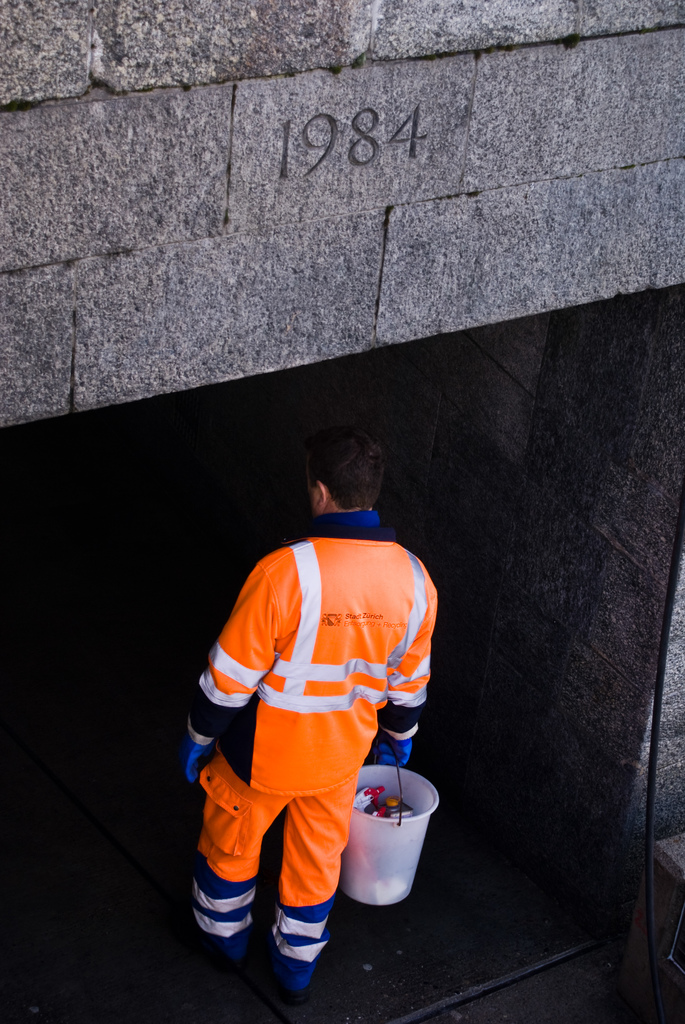How does the uniform he's wearing assist with his job? The bright orange uniform with reflective stripes is crucial for safety, ensuring high visibility in low-light conditions within the tunnel, which is essential for preventing accidents. What kind of tools or equipment might he carry in the bucket? Typically, the bucket may contain tools like wrenches, pliers, or brushes, as well as safety equipment or cleaning supplies needed for tunnel maintenance tasks. 